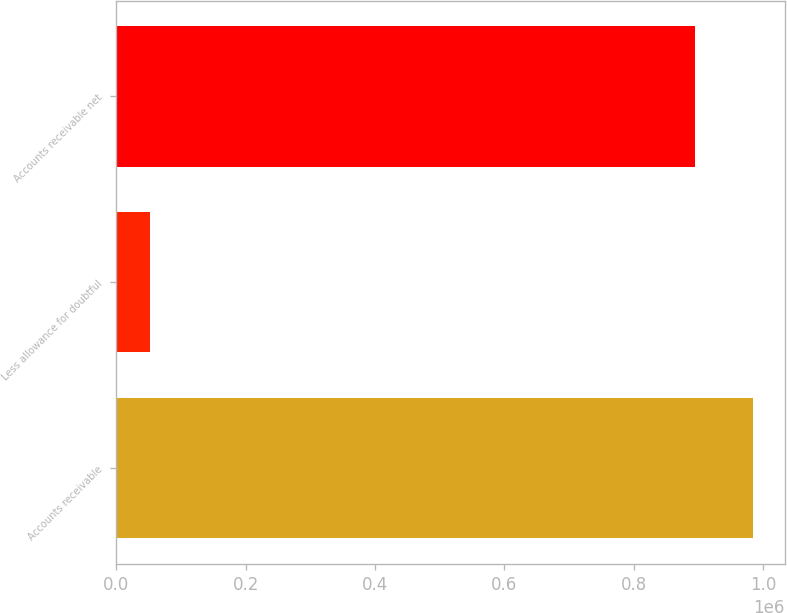Convert chart. <chart><loc_0><loc_0><loc_500><loc_500><bar_chart><fcel>Accounts receivable<fcel>Less allowance for doubtful<fcel>Accounts receivable net<nl><fcel>984224<fcel>51920<fcel>894749<nl></chart> 